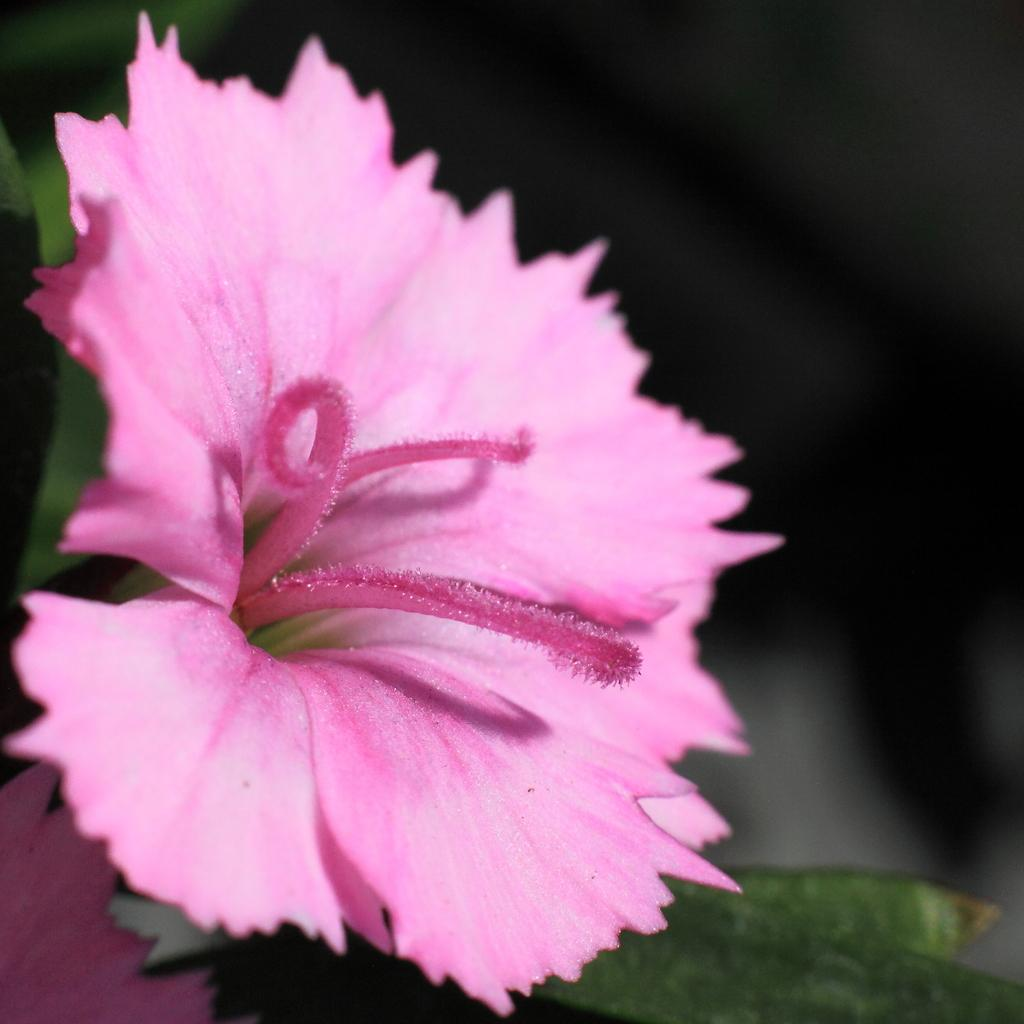What is present in the image? There is a flower in the image. Can you describe the flower in the image? The flower is pink in color. What type of discussion is taking place around the flower in the image? There is no discussion present in the image; it only features a pink flower. What type of beverage is being served alongside the flower in the image? There is no beverage present in the image; it only features a pink flower. 